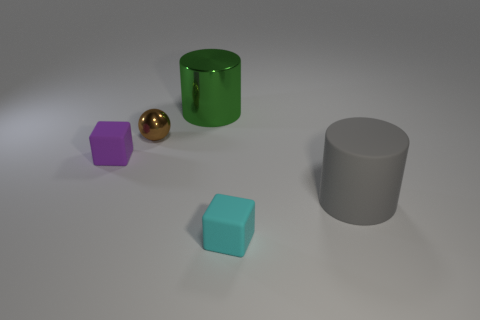Add 2 small metal objects. How many objects exist? 7 Subtract all cubes. How many objects are left? 3 Add 3 purple cubes. How many purple cubes are left? 4 Add 4 gray cylinders. How many gray cylinders exist? 5 Subtract 0 green blocks. How many objects are left? 5 Subtract all cyan matte things. Subtract all tiny purple matte objects. How many objects are left? 3 